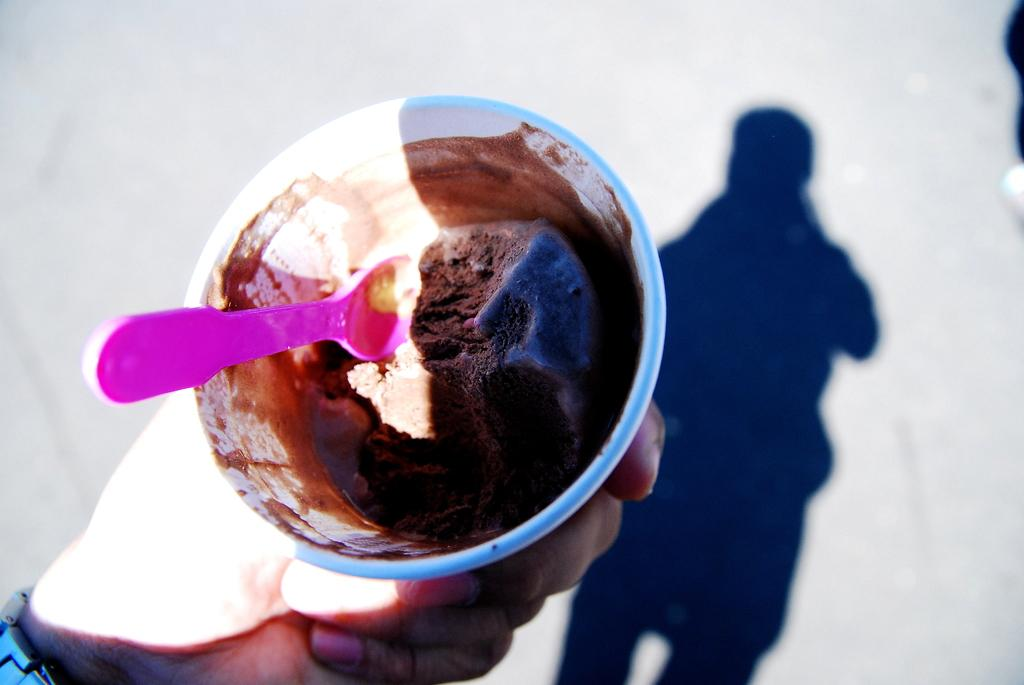What is the main object in the image? There is an ice cream cup in the image. Who is holding the ice cream cup? A person is holding the ice cream cup. What can be seen on the floor in the image? There is a shadow of a person on the floor. What is used to eat the ice cream in the cup? There is a small spoon in the ice cream cup. What type of comb is the laborer using in the image? There is no laborer or comb present in the image. Is the spy visible in the image? There is no spy present in the image. 